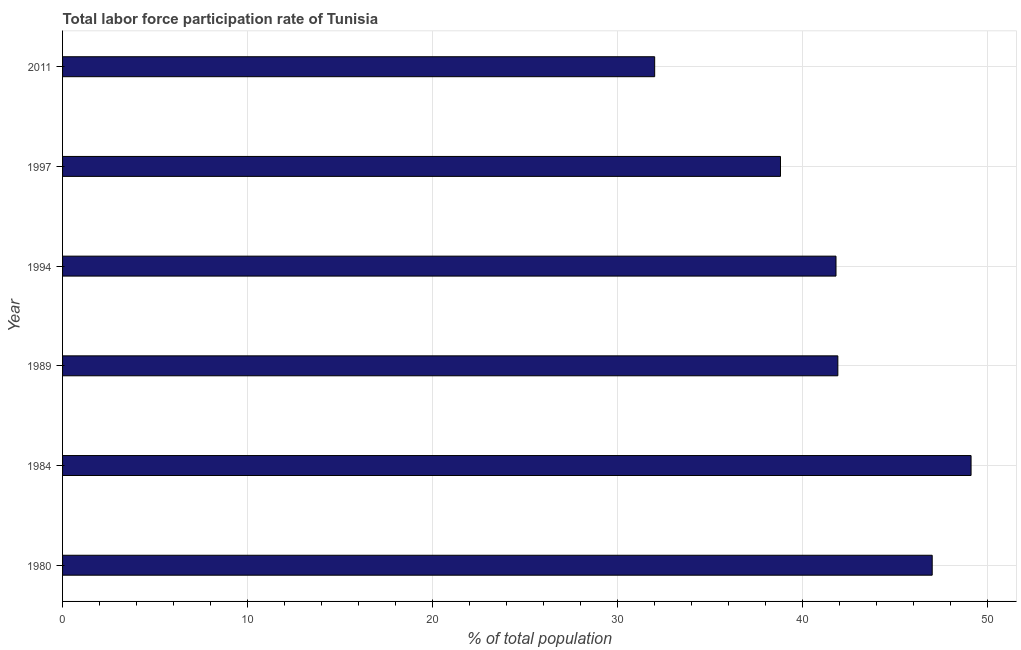Does the graph contain any zero values?
Ensure brevity in your answer.  No. Does the graph contain grids?
Offer a terse response. Yes. What is the title of the graph?
Offer a very short reply. Total labor force participation rate of Tunisia. What is the label or title of the X-axis?
Your response must be concise. % of total population. What is the label or title of the Y-axis?
Provide a succinct answer. Year. What is the total labor force participation rate in 1994?
Provide a short and direct response. 41.8. Across all years, what is the maximum total labor force participation rate?
Ensure brevity in your answer.  49.1. In which year was the total labor force participation rate maximum?
Provide a succinct answer. 1984. What is the sum of the total labor force participation rate?
Give a very brief answer. 250.6. What is the difference between the total labor force participation rate in 1980 and 1984?
Offer a terse response. -2.1. What is the average total labor force participation rate per year?
Your answer should be compact. 41.77. What is the median total labor force participation rate?
Provide a succinct answer. 41.85. In how many years, is the total labor force participation rate greater than 30 %?
Provide a short and direct response. 6. What is the ratio of the total labor force participation rate in 1994 to that in 2011?
Keep it short and to the point. 1.31. Is the total labor force participation rate in 1994 less than that in 2011?
Keep it short and to the point. No. What is the difference between the highest and the lowest total labor force participation rate?
Offer a very short reply. 17.1. In how many years, is the total labor force participation rate greater than the average total labor force participation rate taken over all years?
Offer a terse response. 4. Are all the bars in the graph horizontal?
Provide a short and direct response. Yes. What is the difference between two consecutive major ticks on the X-axis?
Provide a succinct answer. 10. What is the % of total population in 1984?
Provide a succinct answer. 49.1. What is the % of total population of 1989?
Offer a very short reply. 41.9. What is the % of total population in 1994?
Offer a terse response. 41.8. What is the % of total population of 1997?
Ensure brevity in your answer.  38.8. What is the % of total population in 2011?
Ensure brevity in your answer.  32. What is the difference between the % of total population in 1980 and 1994?
Your answer should be compact. 5.2. What is the difference between the % of total population in 1984 and 1989?
Offer a terse response. 7.2. What is the difference between the % of total population in 1984 and 1994?
Your answer should be compact. 7.3. What is the difference between the % of total population in 1984 and 1997?
Make the answer very short. 10.3. What is the difference between the % of total population in 1984 and 2011?
Your response must be concise. 17.1. What is the difference between the % of total population in 1989 and 1997?
Your answer should be very brief. 3.1. What is the difference between the % of total population in 1989 and 2011?
Provide a succinct answer. 9.9. What is the ratio of the % of total population in 1980 to that in 1984?
Keep it short and to the point. 0.96. What is the ratio of the % of total population in 1980 to that in 1989?
Offer a terse response. 1.12. What is the ratio of the % of total population in 1980 to that in 1994?
Your answer should be compact. 1.12. What is the ratio of the % of total population in 1980 to that in 1997?
Offer a very short reply. 1.21. What is the ratio of the % of total population in 1980 to that in 2011?
Offer a terse response. 1.47. What is the ratio of the % of total population in 1984 to that in 1989?
Make the answer very short. 1.17. What is the ratio of the % of total population in 1984 to that in 1994?
Your response must be concise. 1.18. What is the ratio of the % of total population in 1984 to that in 1997?
Your response must be concise. 1.26. What is the ratio of the % of total population in 1984 to that in 2011?
Give a very brief answer. 1.53. What is the ratio of the % of total population in 1989 to that in 1997?
Ensure brevity in your answer.  1.08. What is the ratio of the % of total population in 1989 to that in 2011?
Provide a succinct answer. 1.31. What is the ratio of the % of total population in 1994 to that in 1997?
Offer a terse response. 1.08. What is the ratio of the % of total population in 1994 to that in 2011?
Give a very brief answer. 1.31. What is the ratio of the % of total population in 1997 to that in 2011?
Your answer should be very brief. 1.21. 